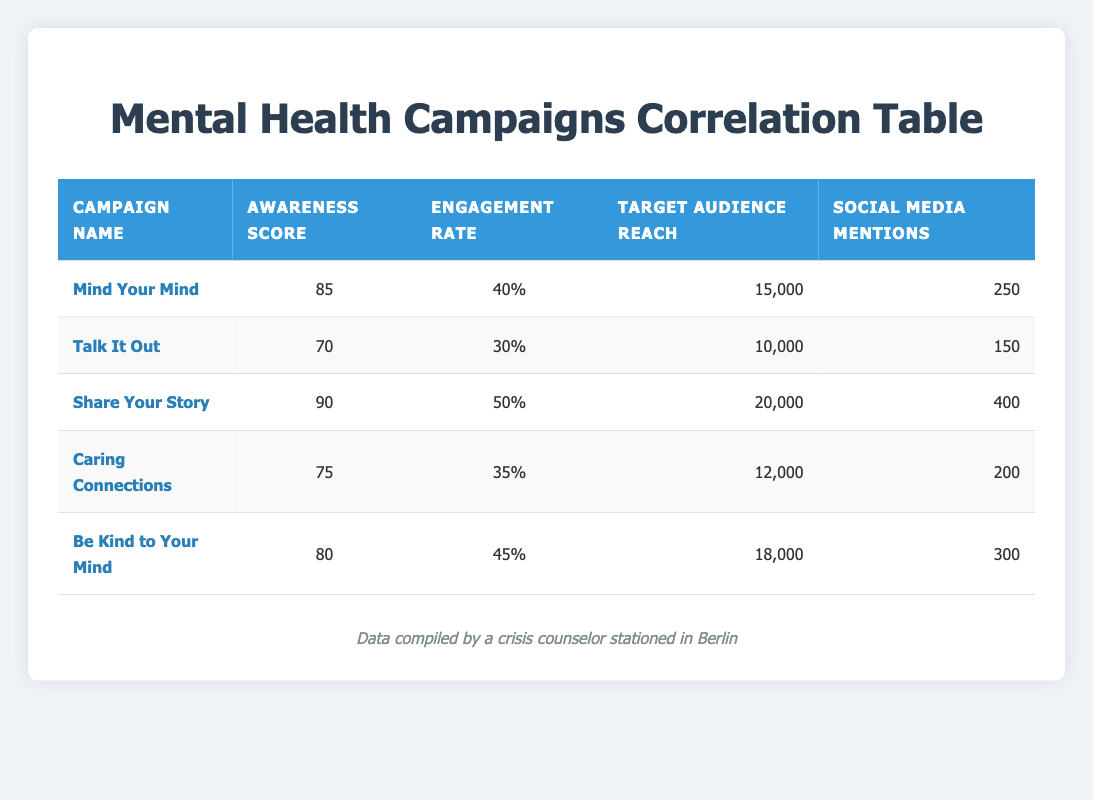What is the campaign with the highest awareness score? By looking at the "Awareness Score" column, "Share Your Story" has the highest score of 90.
Answer: Share Your Story What is the engagement rate for "Be Kind to Your Mind"? The engagement rate for "Be Kind to Your Mind" is listed directly in the table under the "Engagement Rate" column, which is 45%.
Answer: 45% What is the average target audience reach for all campaigns? Summing up the target audience reach: 15000 + 10000 + 20000 + 12000 + 18000 = 85000. There are 5 campaigns, so the average is 85000/5 = 17000.
Answer: 17000 Is "Talk It Out" among the top three campaigns in terms of social media mentions? The social media mentions for "Talk It Out" is 150. Checking the table, the three highest mentions are 400, 300, and 250 for "Share Your Story", "Be Kind to Your Mind", and "Mind Your Mind", respectively. "Talk It Out" does not rank in the top three.
Answer: No What is the difference in engagement rates between the campaigns with the highest and lowest awareness scores? The highest awareness score is 90 from "Share Your Story" (engagement rate 50%), and the lowest is 70 from "Talk It Out" (engagement rate 30%). The difference in engagement rates is 50% - 30% = 20%.
Answer: 20% Which campaign had the widest reach, and what was the engagement rate associated with it? The "Share Your Story" campaign had the largest reach of 20000 and an engagement rate of 50%.
Answer: Share Your Story, 50% Are there any campaigns where the engagement rate is greater than the awareness score? "Mind Your Mind" has an engagement rate of 40% which is less than its awareness score of 85%. "Share Your Story" has an engagement rate of 50% which is less than its 90 awareness score. All campaigns have engagement rates lower than awareness scores.
Answer: No What is the total number of social media mentions across all campaigns? Adding together the social media mentions: 250 + 150 + 400 + 200 + 300 = 1350.
Answer: 1350 